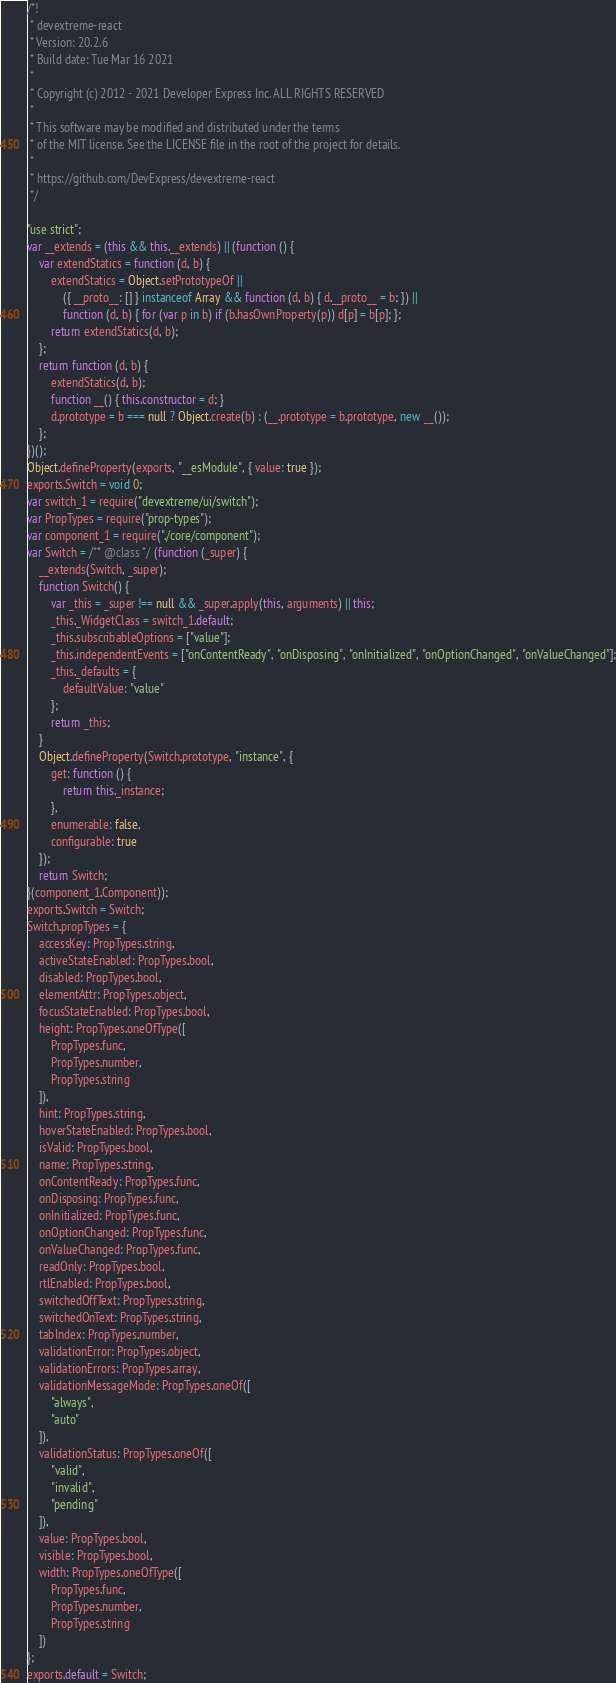<code> <loc_0><loc_0><loc_500><loc_500><_JavaScript_>/*!
 * devextreme-react
 * Version: 20.2.6
 * Build date: Tue Mar 16 2021
 *
 * Copyright (c) 2012 - 2021 Developer Express Inc. ALL RIGHTS RESERVED
 *
 * This software may be modified and distributed under the terms
 * of the MIT license. See the LICENSE file in the root of the project for details.
 *
 * https://github.com/DevExpress/devextreme-react
 */

"use strict";
var __extends = (this && this.__extends) || (function () {
    var extendStatics = function (d, b) {
        extendStatics = Object.setPrototypeOf ||
            ({ __proto__: [] } instanceof Array && function (d, b) { d.__proto__ = b; }) ||
            function (d, b) { for (var p in b) if (b.hasOwnProperty(p)) d[p] = b[p]; };
        return extendStatics(d, b);
    };
    return function (d, b) {
        extendStatics(d, b);
        function __() { this.constructor = d; }
        d.prototype = b === null ? Object.create(b) : (__.prototype = b.prototype, new __());
    };
})();
Object.defineProperty(exports, "__esModule", { value: true });
exports.Switch = void 0;
var switch_1 = require("devextreme/ui/switch");
var PropTypes = require("prop-types");
var component_1 = require("./core/component");
var Switch = /** @class */ (function (_super) {
    __extends(Switch, _super);
    function Switch() {
        var _this = _super !== null && _super.apply(this, arguments) || this;
        _this._WidgetClass = switch_1.default;
        _this.subscribableOptions = ["value"];
        _this.independentEvents = ["onContentReady", "onDisposing", "onInitialized", "onOptionChanged", "onValueChanged"];
        _this._defaults = {
            defaultValue: "value"
        };
        return _this;
    }
    Object.defineProperty(Switch.prototype, "instance", {
        get: function () {
            return this._instance;
        },
        enumerable: false,
        configurable: true
    });
    return Switch;
}(component_1.Component));
exports.Switch = Switch;
Switch.propTypes = {
    accessKey: PropTypes.string,
    activeStateEnabled: PropTypes.bool,
    disabled: PropTypes.bool,
    elementAttr: PropTypes.object,
    focusStateEnabled: PropTypes.bool,
    height: PropTypes.oneOfType([
        PropTypes.func,
        PropTypes.number,
        PropTypes.string
    ]),
    hint: PropTypes.string,
    hoverStateEnabled: PropTypes.bool,
    isValid: PropTypes.bool,
    name: PropTypes.string,
    onContentReady: PropTypes.func,
    onDisposing: PropTypes.func,
    onInitialized: PropTypes.func,
    onOptionChanged: PropTypes.func,
    onValueChanged: PropTypes.func,
    readOnly: PropTypes.bool,
    rtlEnabled: PropTypes.bool,
    switchedOffText: PropTypes.string,
    switchedOnText: PropTypes.string,
    tabIndex: PropTypes.number,
    validationError: PropTypes.object,
    validationErrors: PropTypes.array,
    validationMessageMode: PropTypes.oneOf([
        "always",
        "auto"
    ]),
    validationStatus: PropTypes.oneOf([
        "valid",
        "invalid",
        "pending"
    ]),
    value: PropTypes.bool,
    visible: PropTypes.bool,
    width: PropTypes.oneOfType([
        PropTypes.func,
        PropTypes.number,
        PropTypes.string
    ])
};
exports.default = Switch;
</code> 